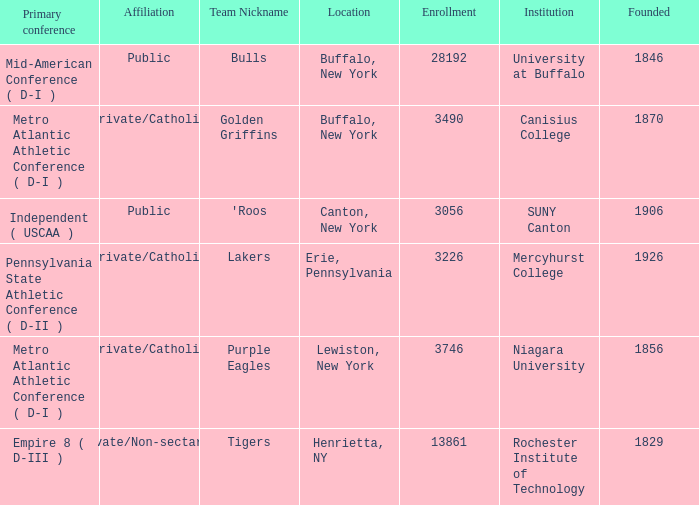What affiliation is Erie, Pennsylvania? Private/Catholic. 